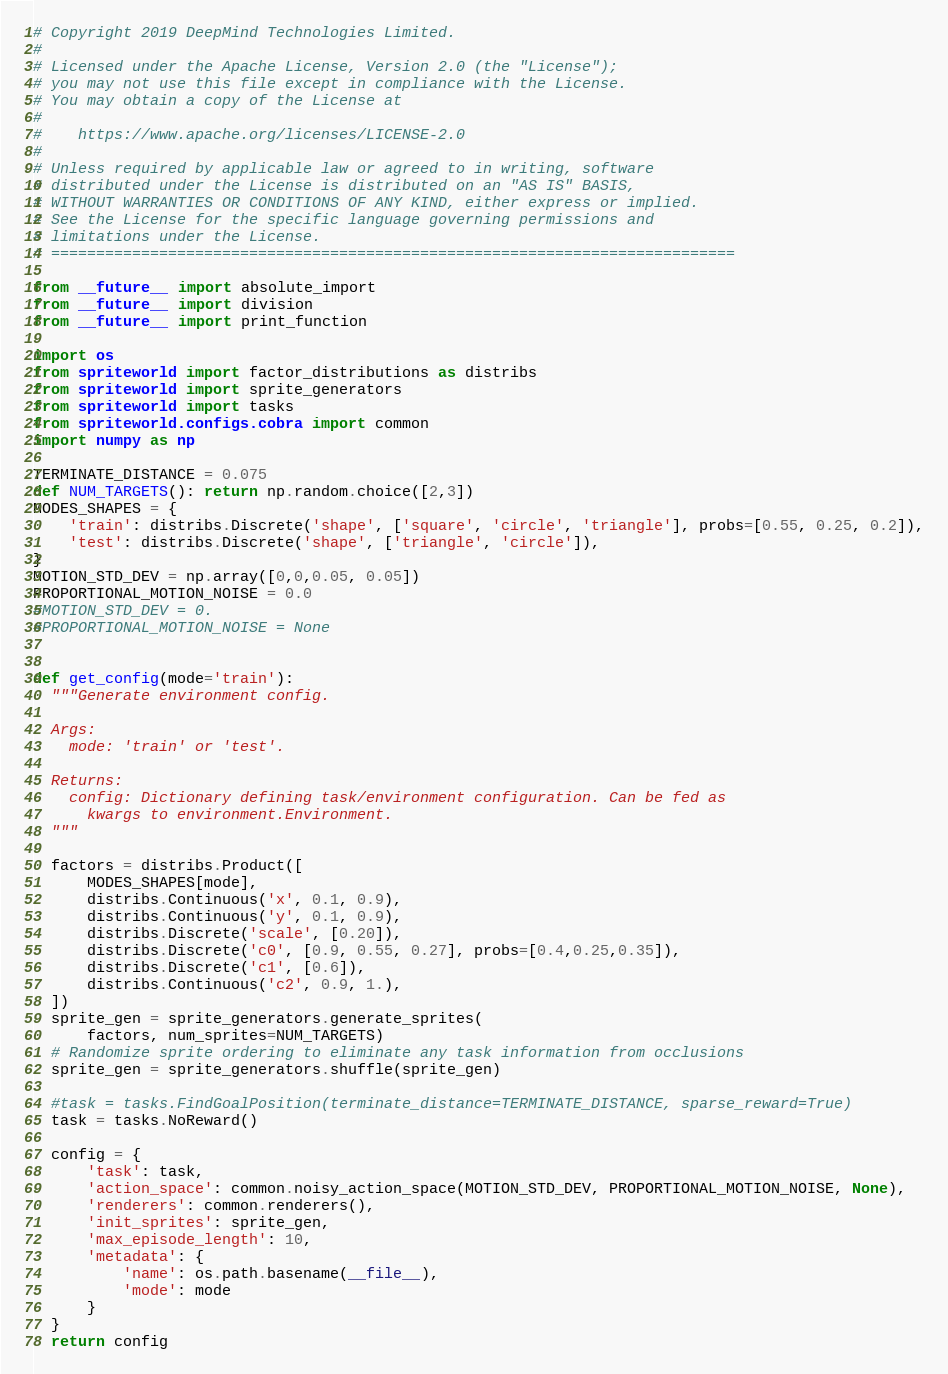Convert code to text. <code><loc_0><loc_0><loc_500><loc_500><_Python_># Copyright 2019 DeepMind Technologies Limited.
#
# Licensed under the Apache License, Version 2.0 (the "License");
# you may not use this file except in compliance with the License.
# You may obtain a copy of the License at
#
#    https://www.apache.org/licenses/LICENSE-2.0
#
# Unless required by applicable law or agreed to in writing, software
# distributed under the License is distributed on an "AS IS" BASIS,
# WITHOUT WARRANTIES OR CONDITIONS OF ANY KIND, either express or implied.
# See the License for the specific language governing permissions and
# limitations under the License.
# ============================================================================

from __future__ import absolute_import
from __future__ import division
from __future__ import print_function

import os
from spriteworld import factor_distributions as distribs
from spriteworld import sprite_generators
from spriteworld import tasks
from spriteworld.configs.cobra import common
import numpy as np

TERMINATE_DISTANCE = 0.075
def NUM_TARGETS(): return np.random.choice([2,3])
MODES_SHAPES = {
    'train': distribs.Discrete('shape', ['square', 'circle', 'triangle'], probs=[0.55, 0.25, 0.2]),
    'test': distribs.Discrete('shape', ['triangle', 'circle']),
}
MOTION_STD_DEV = np.array([0,0,0.05, 0.05])
PROPORTIONAL_MOTION_NOISE = 0.0
#MOTION_STD_DEV = 0.
#PROPORTIONAL_MOTION_NOISE = None


def get_config(mode='train'):
  """Generate environment config.

  Args:
    mode: 'train' or 'test'.

  Returns:
    config: Dictionary defining task/environment configuration. Can be fed as
      kwargs to environment.Environment.
  """

  factors = distribs.Product([
      MODES_SHAPES[mode],
      distribs.Continuous('x', 0.1, 0.9),
      distribs.Continuous('y', 0.1, 0.9),
      distribs.Discrete('scale', [0.20]),
      distribs.Discrete('c0', [0.9, 0.55, 0.27], probs=[0.4,0.25,0.35]),
      distribs.Discrete('c1', [0.6]),
      distribs.Continuous('c2', 0.9, 1.),
  ])
  sprite_gen = sprite_generators.generate_sprites(
      factors, num_sprites=NUM_TARGETS)
  # Randomize sprite ordering to eliminate any task information from occlusions
  sprite_gen = sprite_generators.shuffle(sprite_gen)

  #task = tasks.FindGoalPosition(terminate_distance=TERMINATE_DISTANCE, sparse_reward=True)
  task = tasks.NoReward()

  config = {
      'task': task,
      'action_space': common.noisy_action_space(MOTION_STD_DEV, PROPORTIONAL_MOTION_NOISE, None),
      'renderers': common.renderers(),
      'init_sprites': sprite_gen,
      'max_episode_length': 10,
      'metadata': {
          'name': os.path.basename(__file__),
          'mode': mode
      }
  }
  return config
</code> 